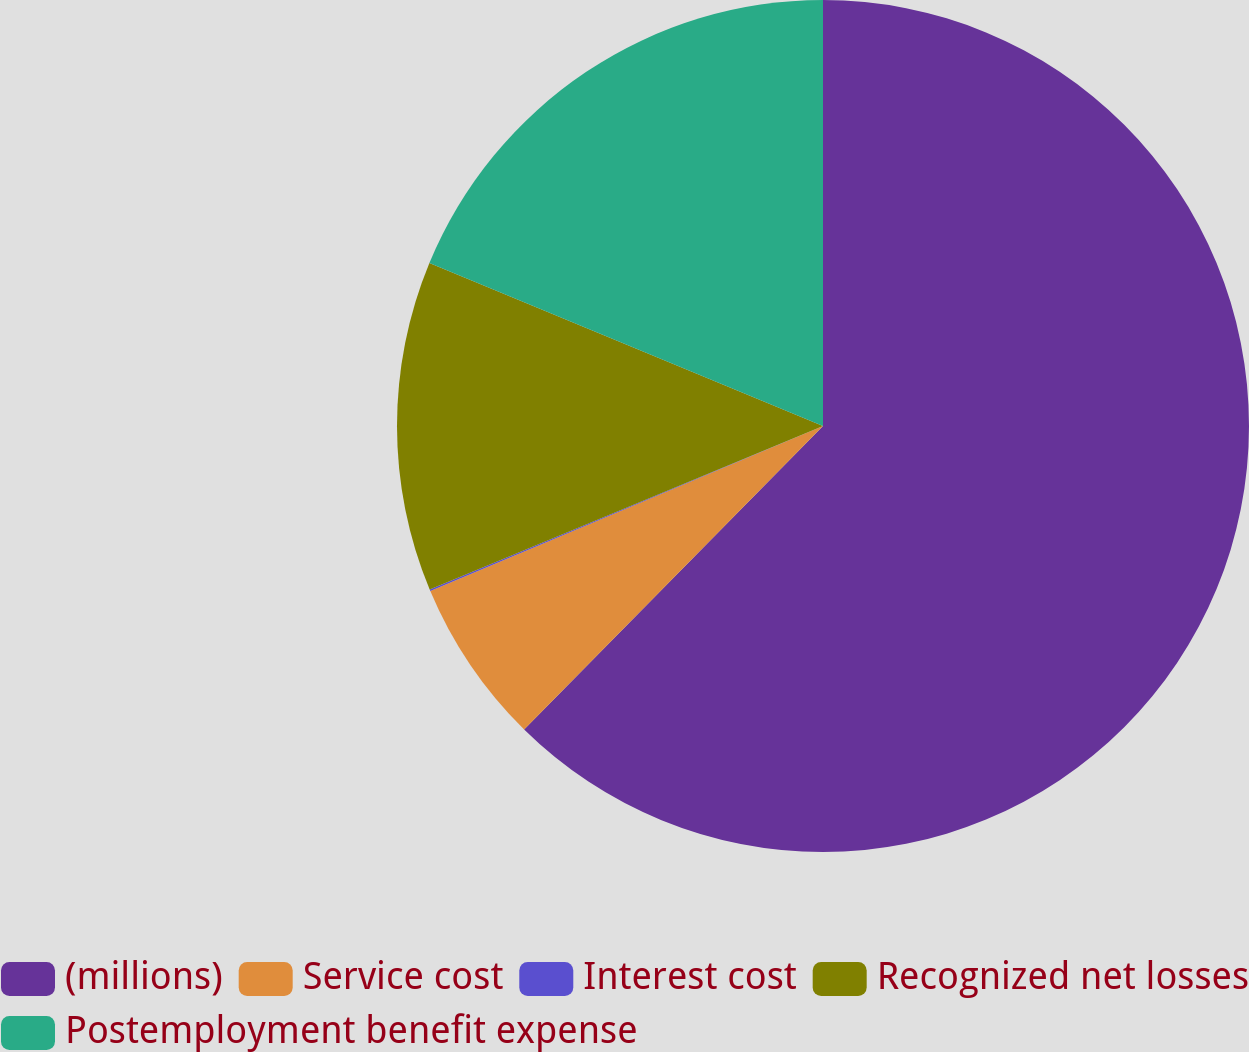Convert chart to OTSL. <chart><loc_0><loc_0><loc_500><loc_500><pie_chart><fcel>(millions)<fcel>Service cost<fcel>Interest cost<fcel>Recognized net losses<fcel>Postemployment benefit expense<nl><fcel>62.37%<fcel>6.29%<fcel>0.06%<fcel>12.52%<fcel>18.75%<nl></chart> 